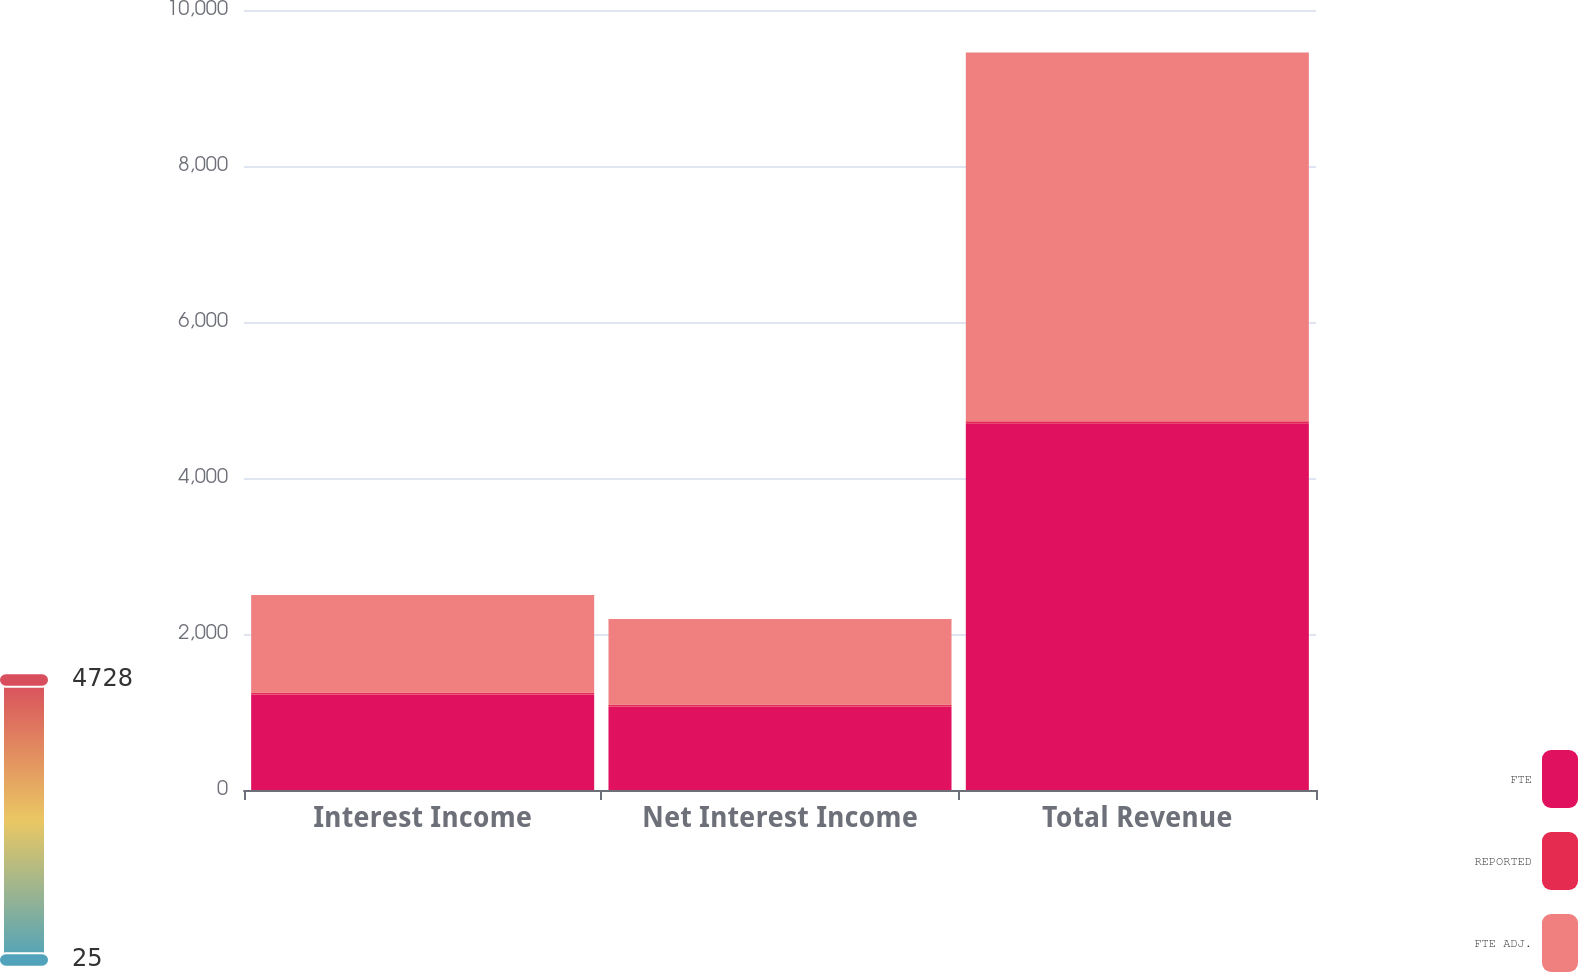<chart> <loc_0><loc_0><loc_500><loc_500><stacked_bar_chart><ecel><fcel>Interest Income<fcel>Net Interest Income<fcel>Total Revenue<nl><fcel>FTE<fcel>1224<fcel>1070.1<fcel>4702.6<nl><fcel>REPORTED<fcel>25.3<fcel>25.3<fcel>25.3<nl><fcel>FTE ADJ.<fcel>1249.3<fcel>1095.4<fcel>4727.9<nl></chart> 